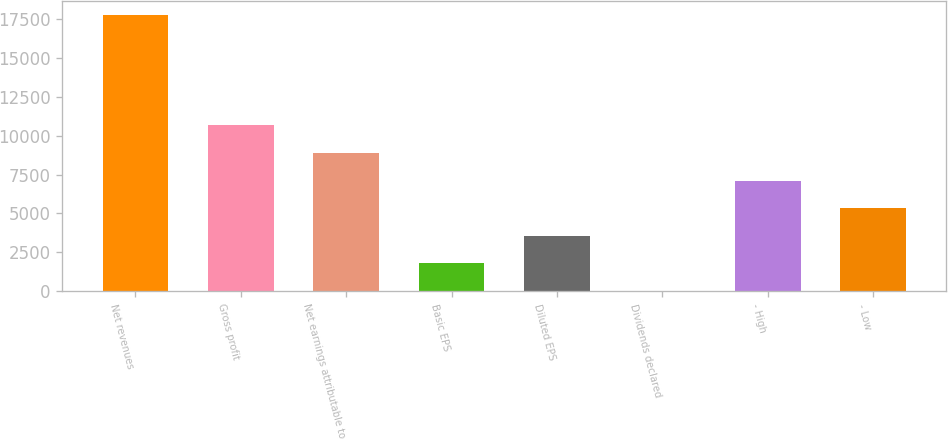Convert chart. <chart><loc_0><loc_0><loc_500><loc_500><bar_chart><fcel>Net revenues<fcel>Gross profit<fcel>Net earnings attributable to<fcel>Basic EPS<fcel>Diluted EPS<fcel>Dividends declared<fcel>- High<fcel>- Low<nl><fcel>17779<fcel>10667.8<fcel>8889.99<fcel>1778.75<fcel>3556.56<fcel>0.94<fcel>7112.18<fcel>5334.37<nl></chart> 